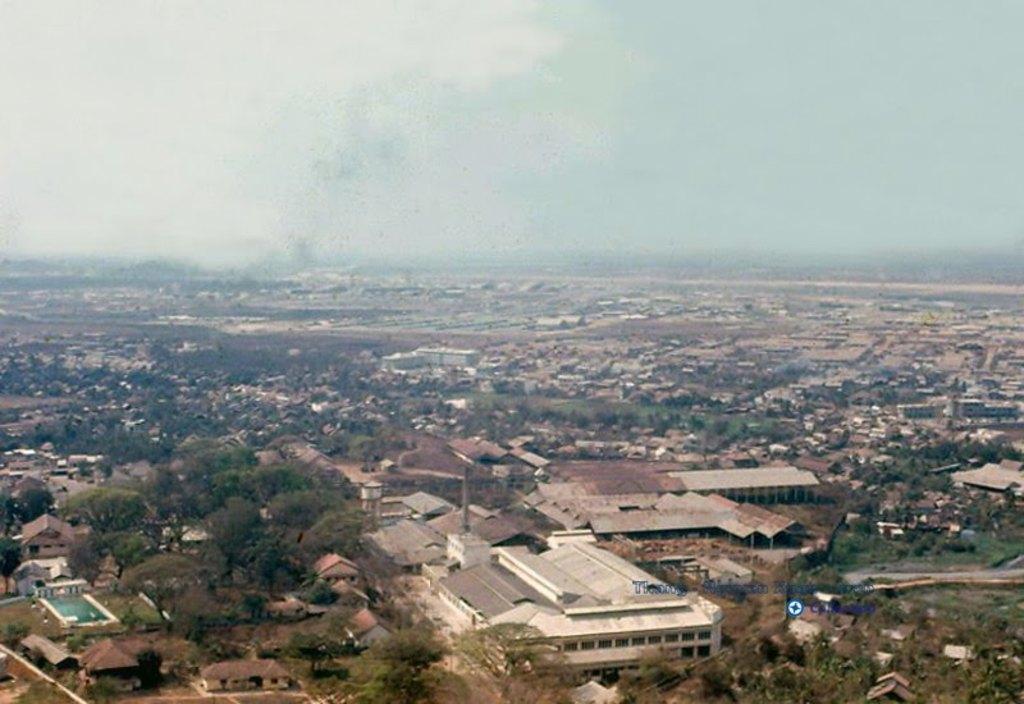Describe this image in one or two sentences. This image is taken outdoors. At the top of the image there is a sky with clouds. In the middle of the image there are many buildings, houses, trees, plants and roads on the ground. 